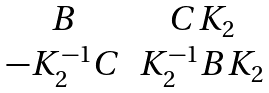<formula> <loc_0><loc_0><loc_500><loc_500>\begin{matrix} B & C K _ { 2 } \\ - K _ { 2 } ^ { - 1 } C & K _ { 2 } ^ { - 1 } B K _ { 2 } \\ \end{matrix}</formula> 